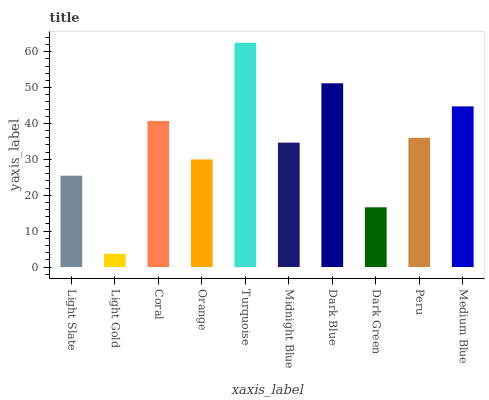Is Light Gold the minimum?
Answer yes or no. Yes. Is Turquoise the maximum?
Answer yes or no. Yes. Is Coral the minimum?
Answer yes or no. No. Is Coral the maximum?
Answer yes or no. No. Is Coral greater than Light Gold?
Answer yes or no. Yes. Is Light Gold less than Coral?
Answer yes or no. Yes. Is Light Gold greater than Coral?
Answer yes or no. No. Is Coral less than Light Gold?
Answer yes or no. No. Is Peru the high median?
Answer yes or no. Yes. Is Midnight Blue the low median?
Answer yes or no. Yes. Is Midnight Blue the high median?
Answer yes or no. No. Is Orange the low median?
Answer yes or no. No. 